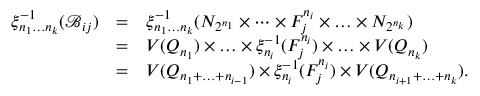<formula> <loc_0><loc_0><loc_500><loc_500>\begin{array} { r c l } { \xi _ { n _ { 1 } \dots n _ { k } } ^ { - 1 } ( \ m a t h s c r { B } _ { i j } ) } & { = } & { \xi _ { n _ { 1 } \dots n _ { k } } ^ { - 1 } ( N _ { 2 ^ { n _ { 1 } } } \times \cdots \times F _ { j } ^ { n _ { i } } \times \dots \times N _ { 2 ^ { n _ { k } } } ) } \\ & { = } & { V ( Q _ { n _ { 1 } } ) \times \dots \times \xi _ { n _ { i } } ^ { - 1 } ( F _ { j } ^ { n _ { i } } ) \times \dots \times V ( Q _ { n _ { k } } ) } \\ & { = } & { V ( Q _ { n _ { 1 } + \dots + n _ { i - 1 } } ) \times \xi _ { n _ { i } } ^ { - 1 } ( F _ { j } ^ { n _ { i } } ) \times V ( Q _ { n _ { i + 1 } + \dots + n _ { k } } ) . } \end{array}</formula> 